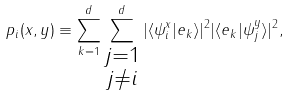<formula> <loc_0><loc_0><loc_500><loc_500>p _ { i } ( x , y ) \equiv \sum _ { k = 1 } ^ { d } \sum _ { \substack { j = 1 \\ j \neq i } } ^ { d } | \langle \psi _ { i } ^ { x } | e _ { k } \rangle | ^ { 2 } | \langle e _ { k } | \psi _ { j } ^ { y } \rangle | ^ { 2 } ,</formula> 